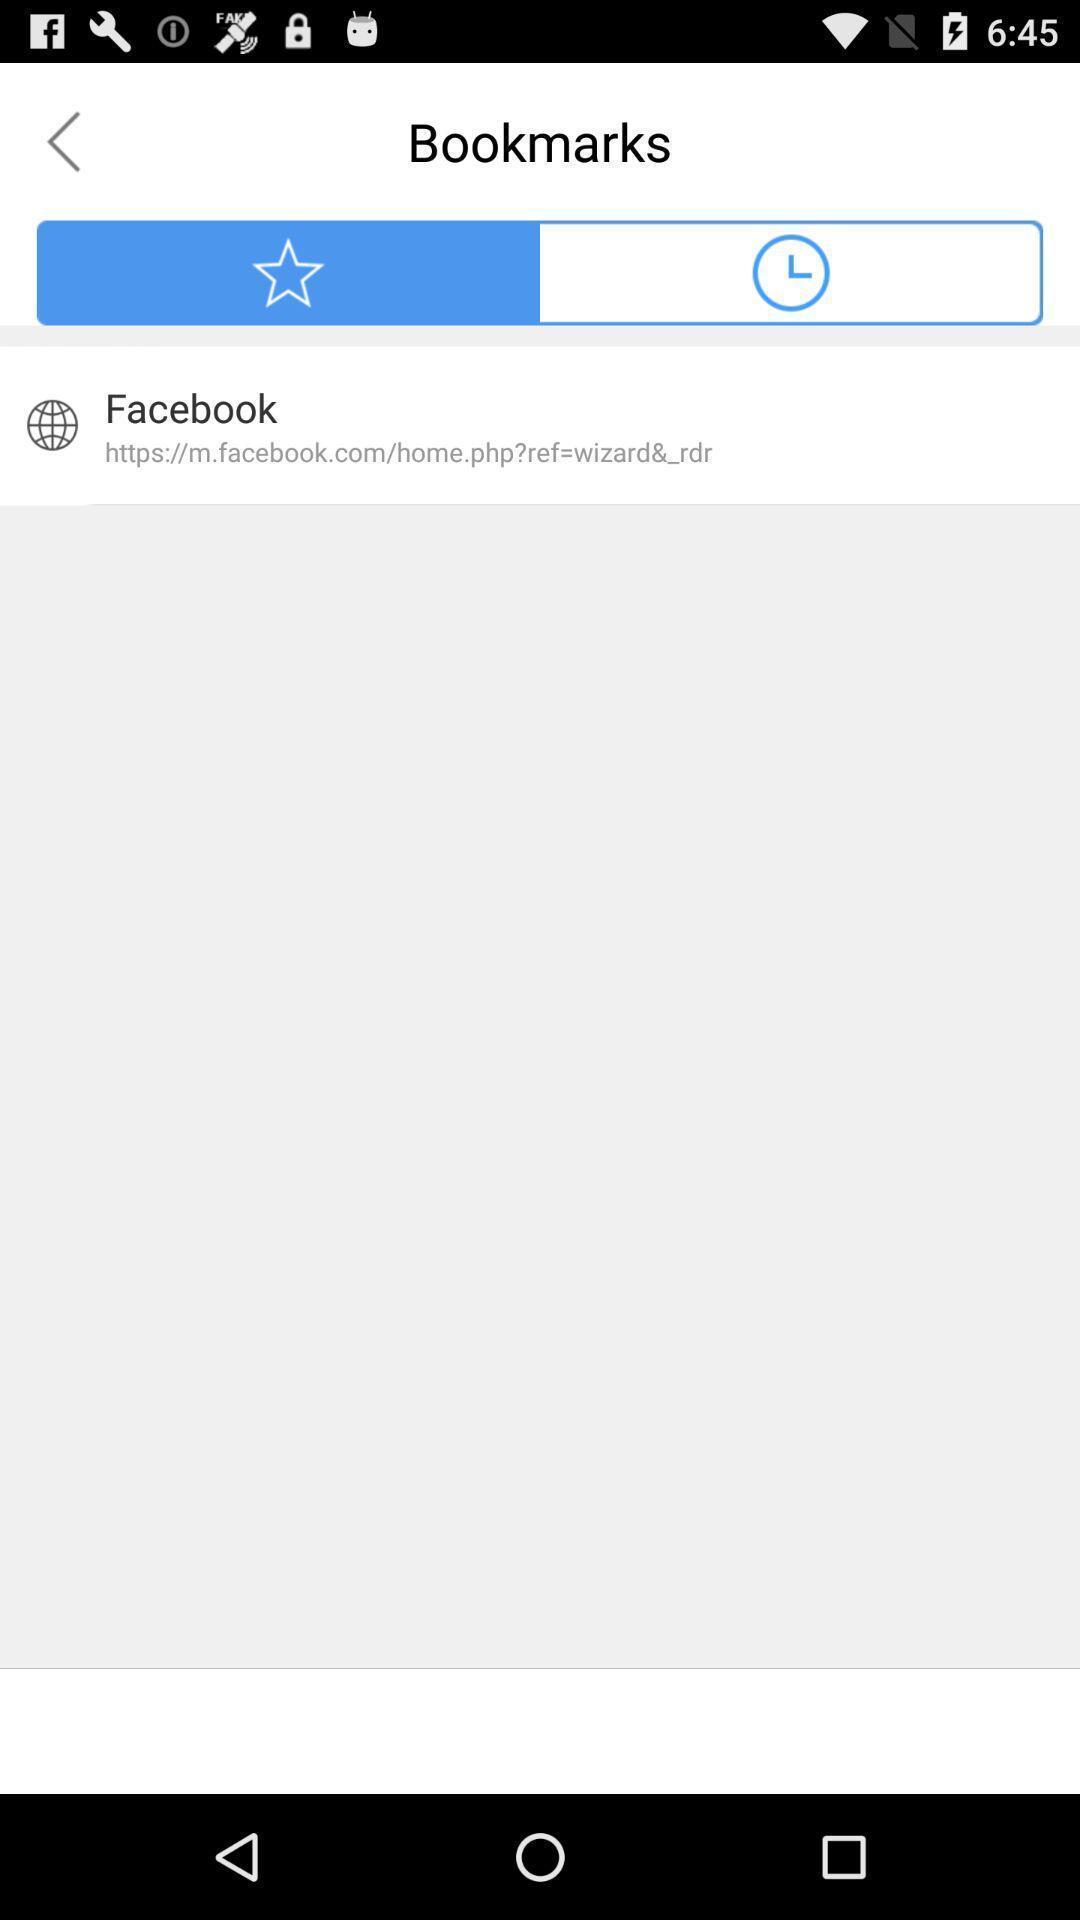Tell me about the visual elements in this screen capture. Page showing list of bookmarks in a web browser. 